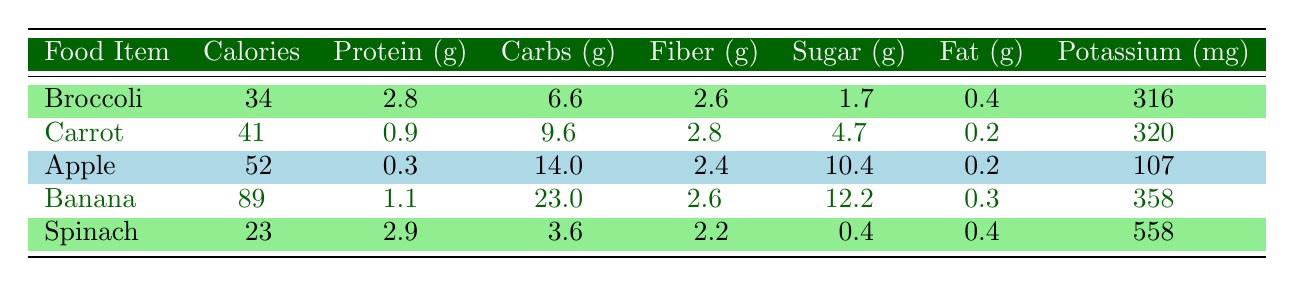What is the calorie content of spinach? The calorie content is found in the "Calories" column for spinach, which is 23.
Answer: 23 Which food item has the highest protein content per 100g? Comparing the protein values: Broccoli has 2.8g, Carrot has 0.9g, Apple has 0.3g, Banana has 1.1g, and Spinach has 2.9g. Spinach has the highest protein content.
Answer: Spinach Is the sugar content of an apple higher than that of a carrot? The sugar content for Apple is 10.4g and for Carrot is 4.7g. Since 10.4g > 4.7g, the statement is true.
Answer: Yes What is the average potassium content of the fruits and vegetables listed? The potassium values are: Broccoli 316mg, Carrot 320mg, Apple 107mg, Banana 358mg, Spinach 558mg. Summing these gives 316 + 320 + 107 + 358 + 558 = 1659mg. Dividing by 5 gives an average of 1659/5 = 331.8mg.
Answer: 331.8 Does banana have more calories than broccoli? The calorie content for Banana is 89 and for Broccoli is 34. Since 89 > 34, the statement is true.
Answer: Yes What is the difference in fiber content between spinach and carrot? Spinach has 2.2g of fiber and Carrot has 2.8g. The difference is calculated as 2.8g - 2.2g = 0.6g.
Answer: 0.6 Which food item has the least amount of fat? Examining the fat content: Broccoli has 0.4g, Carrot has 0.2g, Apple has 0.2g, Banana has 0.3g, and Spinach has 0.4g. Both Carrot and Apple have the lowest fat content at 0.2g.
Answer: Carrot and Apple Count the food items that have more than 40 calories. The food items with calorie counts over 40 are Carrot (41), Apple (52), and Banana (89). So, there are three items in total.
Answer: 3 Which food item has the highest carbohydrate content? The carbohydrate contents are: Broccoli has 6.6g, Carrot has 9.6g, Apple has 14g, Banana has 23g, and Spinach has 3.6g. Comparing these, Banana has the highest carbohydrate content at 23g.
Answer: Banana 